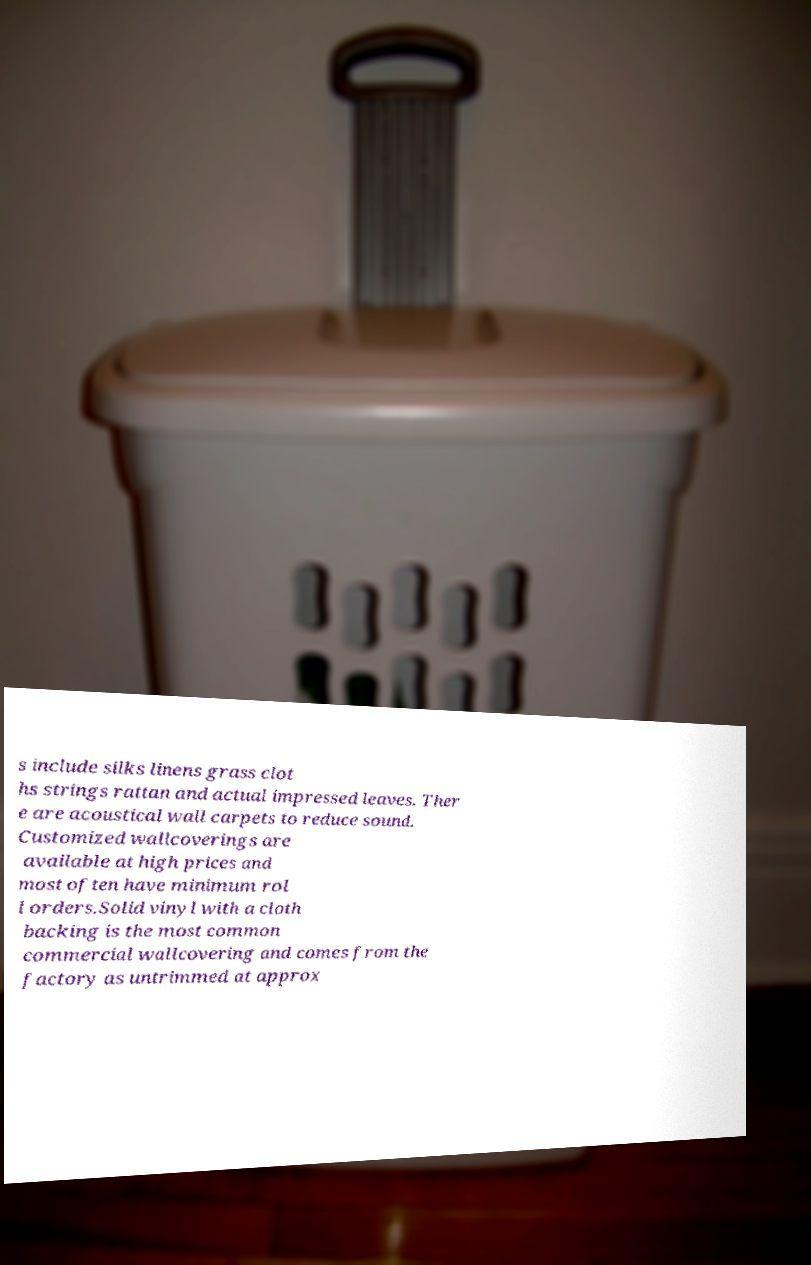Please read and relay the text visible in this image. What does it say? s include silks linens grass clot hs strings rattan and actual impressed leaves. Ther e are acoustical wall carpets to reduce sound. Customized wallcoverings are available at high prices and most often have minimum rol l orders.Solid vinyl with a cloth backing is the most common commercial wallcovering and comes from the factory as untrimmed at approx 